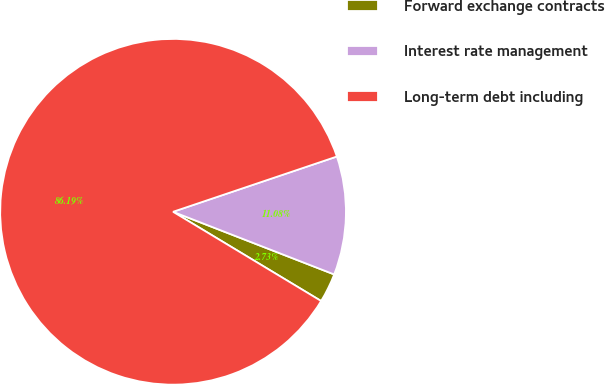<chart> <loc_0><loc_0><loc_500><loc_500><pie_chart><fcel>Forward exchange contracts<fcel>Interest rate management<fcel>Long-term debt including<nl><fcel>2.73%<fcel>11.08%<fcel>86.19%<nl></chart> 